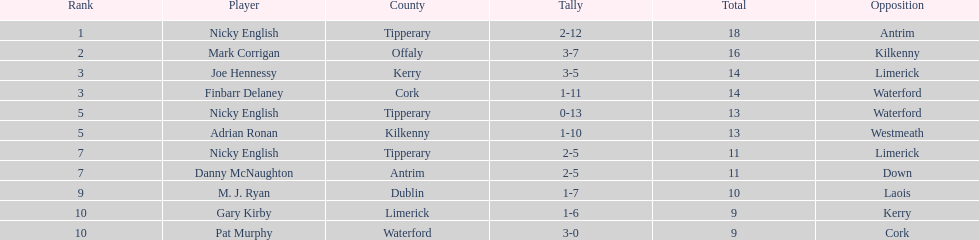What's the count of people on the list? 9. 